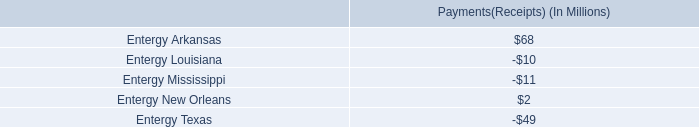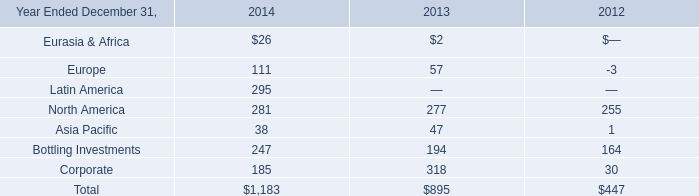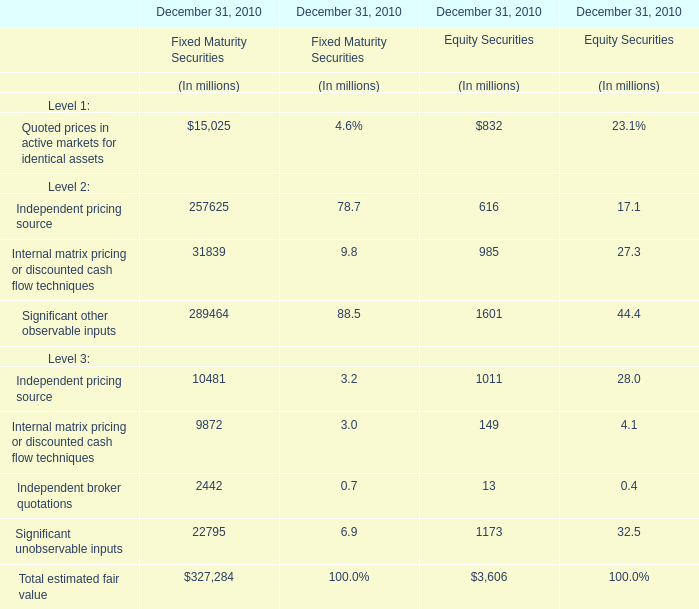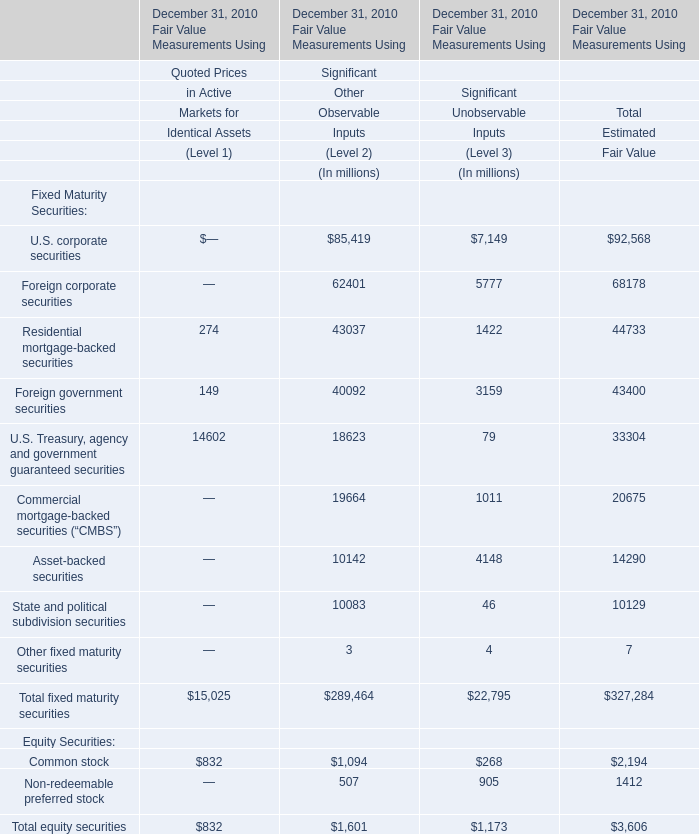What is the sum of Independent pricing source for Fixed Maturity Securities and Common stock for Significant Other Observable Inputs (Level 2)? (in million) 
Computations: (257625 + 1094)
Answer: 258719.0. 